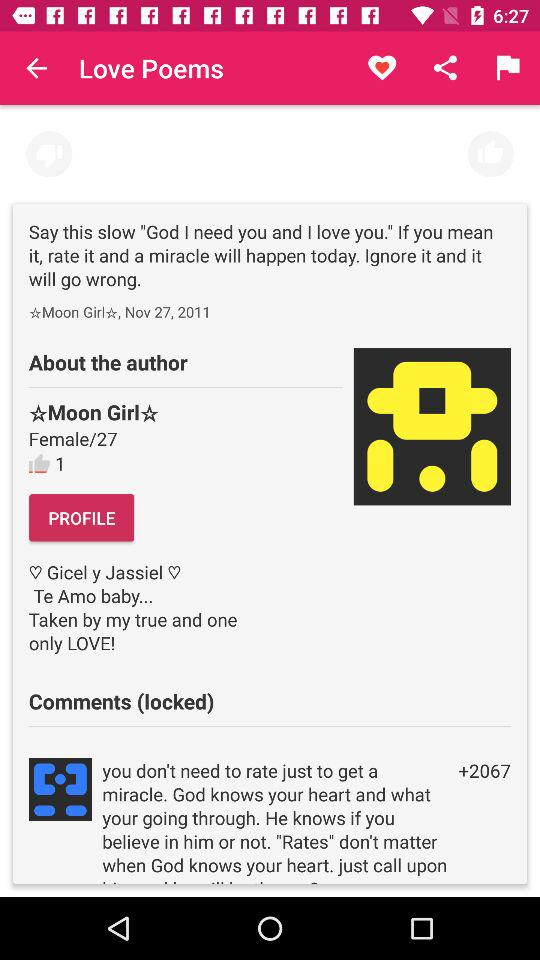How many thumbs up does the post have?
Answer the question using a single word or phrase. 1 